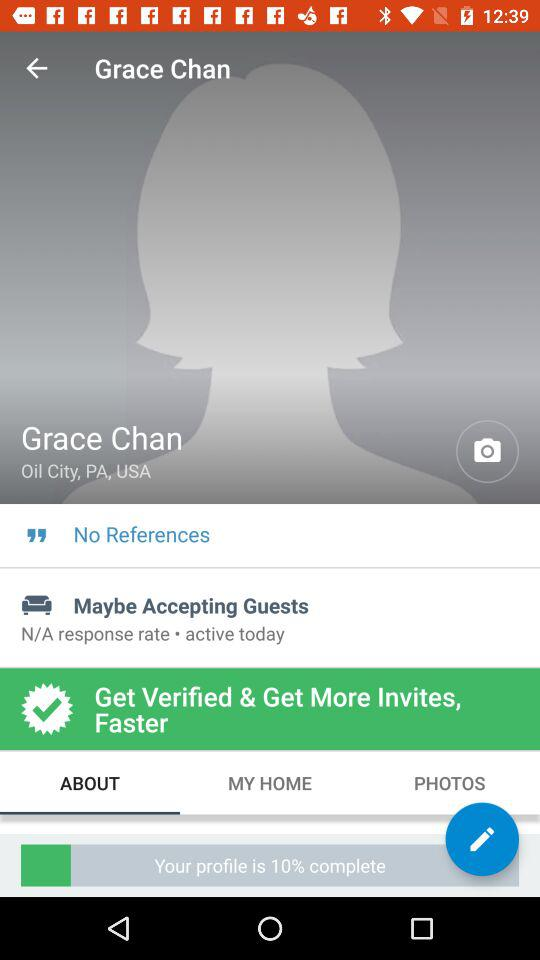What is the response rate of Grace Chan?
Answer the question using a single word or phrase. N/A 